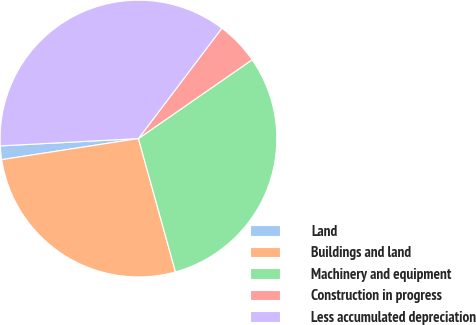Convert chart. <chart><loc_0><loc_0><loc_500><loc_500><pie_chart><fcel>Land<fcel>Buildings and land<fcel>Machinery and equipment<fcel>Construction in progress<fcel>Less accumulated depreciation<nl><fcel>1.59%<fcel>26.88%<fcel>30.34%<fcel>5.05%<fcel>36.15%<nl></chart> 